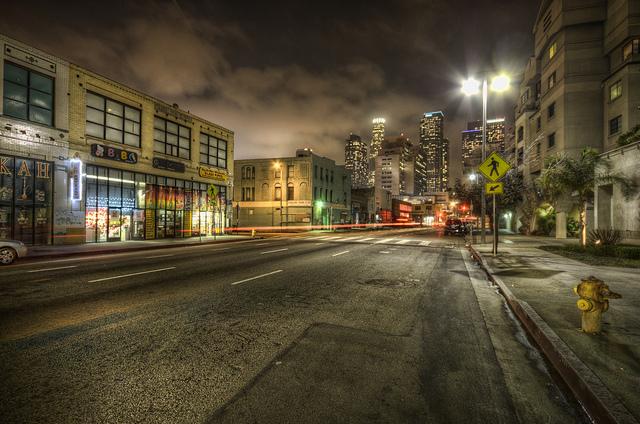What is the yellow object in the front right of the picture?
Short answer required. Fire hydrant. How many streetlights do you see?
Short answer required. 2. Is this a rural area?
Keep it brief. No. 